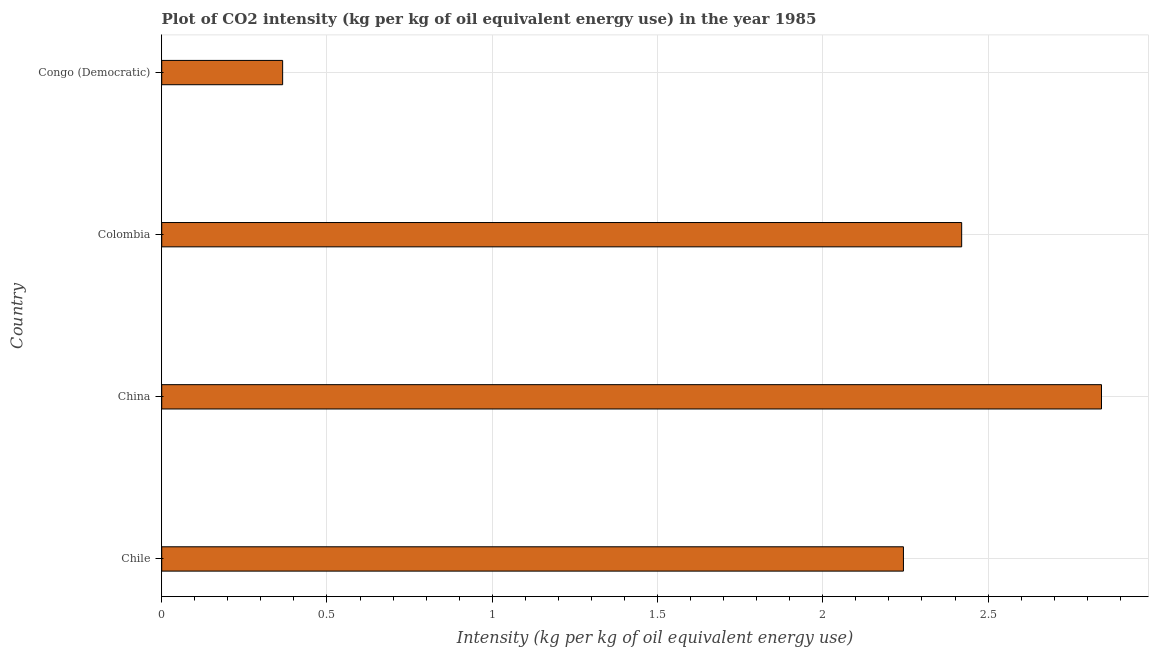What is the title of the graph?
Provide a succinct answer. Plot of CO2 intensity (kg per kg of oil equivalent energy use) in the year 1985. What is the label or title of the X-axis?
Offer a very short reply. Intensity (kg per kg of oil equivalent energy use). What is the co2 intensity in Congo (Democratic)?
Ensure brevity in your answer.  0.37. Across all countries, what is the maximum co2 intensity?
Ensure brevity in your answer.  2.84. Across all countries, what is the minimum co2 intensity?
Keep it short and to the point. 0.37. In which country was the co2 intensity minimum?
Provide a short and direct response. Congo (Democratic). What is the sum of the co2 intensity?
Your response must be concise. 7.87. What is the difference between the co2 intensity in China and Colombia?
Keep it short and to the point. 0.42. What is the average co2 intensity per country?
Offer a very short reply. 1.97. What is the median co2 intensity?
Ensure brevity in your answer.  2.33. What is the ratio of the co2 intensity in China to that in Congo (Democratic)?
Provide a short and direct response. 7.77. Is the co2 intensity in China less than that in Congo (Democratic)?
Your response must be concise. No. What is the difference between the highest and the second highest co2 intensity?
Keep it short and to the point. 0.42. Is the sum of the co2 intensity in Chile and China greater than the maximum co2 intensity across all countries?
Keep it short and to the point. Yes. What is the difference between the highest and the lowest co2 intensity?
Offer a terse response. 2.48. How many bars are there?
Offer a terse response. 4. Are all the bars in the graph horizontal?
Ensure brevity in your answer.  Yes. What is the Intensity (kg per kg of oil equivalent energy use) in Chile?
Your answer should be compact. 2.24. What is the Intensity (kg per kg of oil equivalent energy use) in China?
Make the answer very short. 2.84. What is the Intensity (kg per kg of oil equivalent energy use) of Colombia?
Your answer should be compact. 2.42. What is the Intensity (kg per kg of oil equivalent energy use) of Congo (Democratic)?
Make the answer very short. 0.37. What is the difference between the Intensity (kg per kg of oil equivalent energy use) in Chile and China?
Your answer should be very brief. -0.6. What is the difference between the Intensity (kg per kg of oil equivalent energy use) in Chile and Colombia?
Keep it short and to the point. -0.18. What is the difference between the Intensity (kg per kg of oil equivalent energy use) in Chile and Congo (Democratic)?
Keep it short and to the point. 1.88. What is the difference between the Intensity (kg per kg of oil equivalent energy use) in China and Colombia?
Provide a short and direct response. 0.42. What is the difference between the Intensity (kg per kg of oil equivalent energy use) in China and Congo (Democratic)?
Make the answer very short. 2.48. What is the difference between the Intensity (kg per kg of oil equivalent energy use) in Colombia and Congo (Democratic)?
Ensure brevity in your answer.  2.05. What is the ratio of the Intensity (kg per kg of oil equivalent energy use) in Chile to that in China?
Provide a short and direct response. 0.79. What is the ratio of the Intensity (kg per kg of oil equivalent energy use) in Chile to that in Colombia?
Make the answer very short. 0.93. What is the ratio of the Intensity (kg per kg of oil equivalent energy use) in Chile to that in Congo (Democratic)?
Your answer should be compact. 6.13. What is the ratio of the Intensity (kg per kg of oil equivalent energy use) in China to that in Colombia?
Offer a very short reply. 1.18. What is the ratio of the Intensity (kg per kg of oil equivalent energy use) in China to that in Congo (Democratic)?
Your answer should be compact. 7.77. What is the ratio of the Intensity (kg per kg of oil equivalent energy use) in Colombia to that in Congo (Democratic)?
Ensure brevity in your answer.  6.62. 